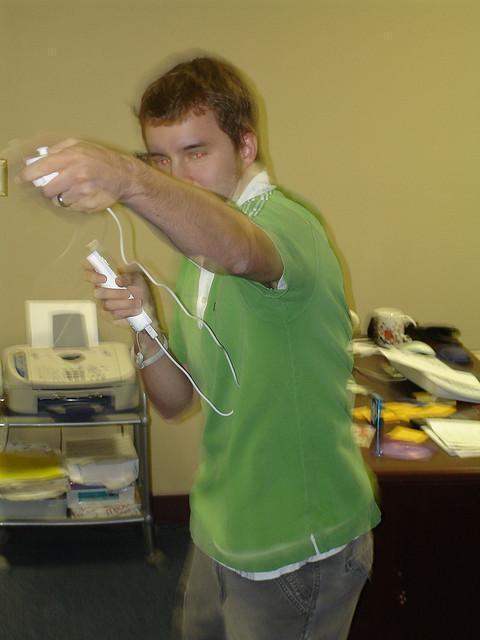What office equipment is on the shelf?
Answer the question by selecting the correct answer among the 4 following choices.
Options: Stapler, fax, copier, computer. Fax. 